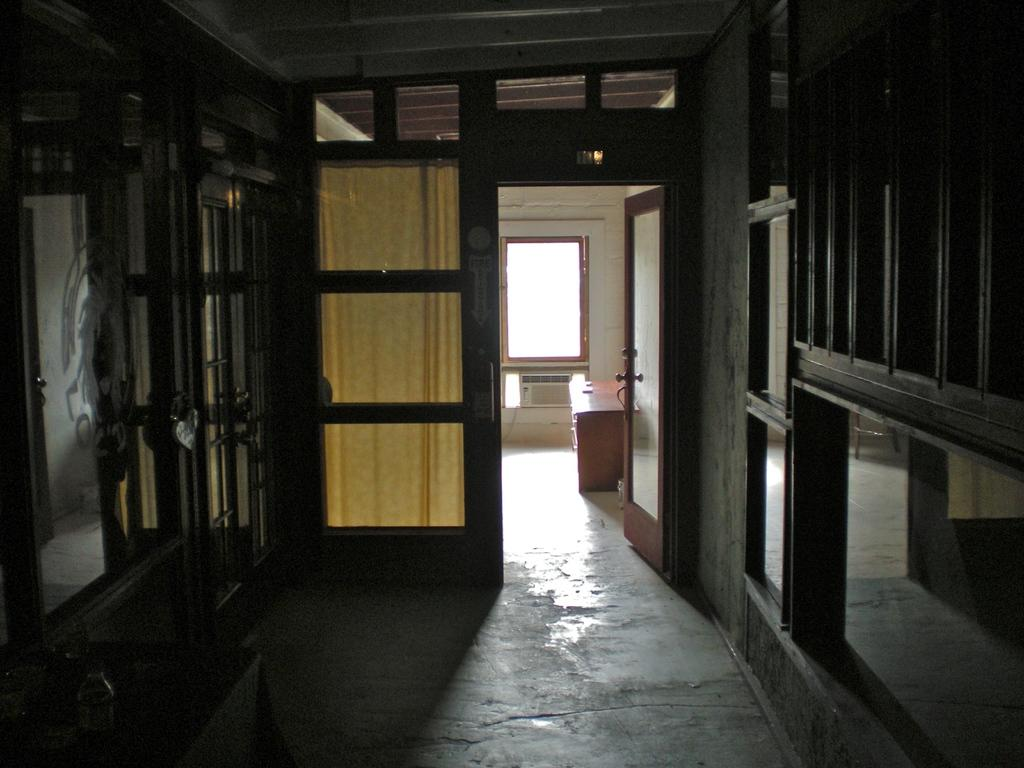What is the main subject of the image? The main subject of the image is the internal structure of a house. Can you identify any specific features of the house in the image? Yes, there is a glass window visible in the image. What part of the house can be seen in the image? The floor is visible in the image. What type of flowers can be seen growing in the tent in the image? There is no tent or flowers present in the image; it shows the internal structure of a house. 